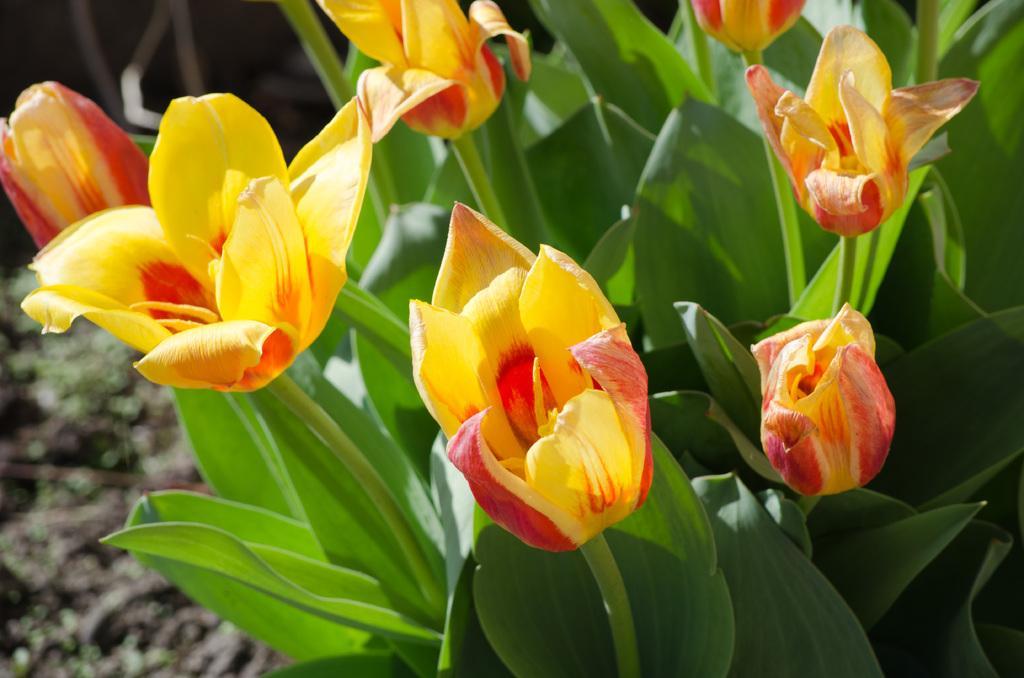In one or two sentences, can you explain what this image depicts? In this picture we can see plants with flowers and in the background we can see the ground and it is blurry. 